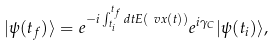<formula> <loc_0><loc_0><loc_500><loc_500>| \psi ( t _ { f } ) \rangle & = e ^ { - i \int _ { t _ { i } } ^ { t _ { f } } d t E ( \ v x ( t ) ) } e ^ { i \gamma _ { C } } | \psi ( t _ { i } ) \rangle ,</formula> 